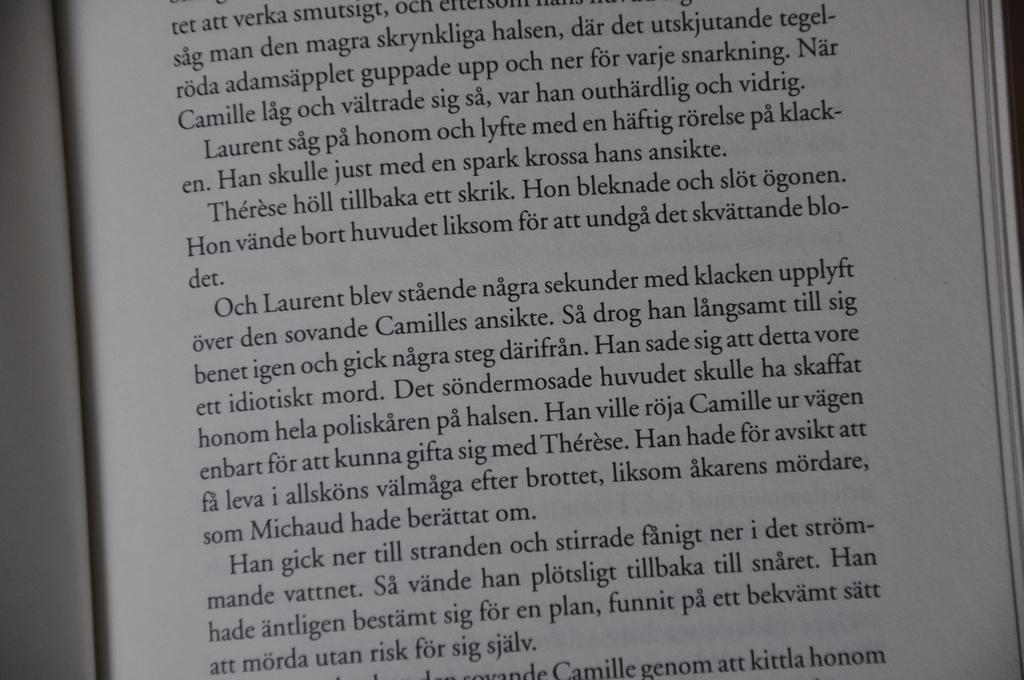Can you describe this image briefly? In this picture we can see a book and we can see text on a paper. 